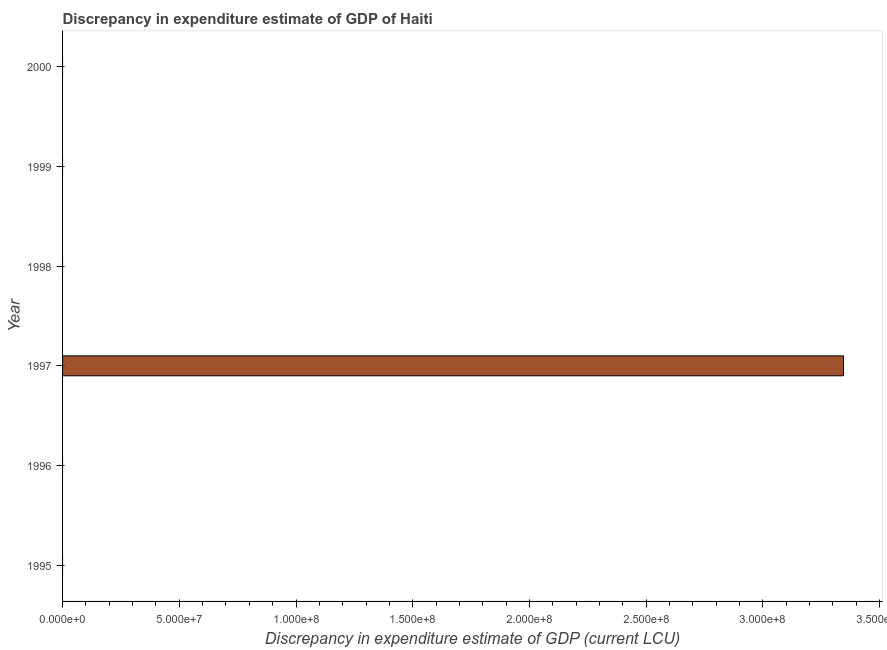Does the graph contain grids?
Provide a short and direct response. No. What is the title of the graph?
Your answer should be very brief. Discrepancy in expenditure estimate of GDP of Haiti. What is the label or title of the X-axis?
Provide a succinct answer. Discrepancy in expenditure estimate of GDP (current LCU). What is the label or title of the Y-axis?
Provide a short and direct response. Year. Across all years, what is the maximum discrepancy in expenditure estimate of gdp?
Your answer should be compact. 3.35e+08. Across all years, what is the minimum discrepancy in expenditure estimate of gdp?
Your response must be concise. 0. In which year was the discrepancy in expenditure estimate of gdp maximum?
Your answer should be compact. 1997. What is the sum of the discrepancy in expenditure estimate of gdp?
Provide a succinct answer. 3.35e+08. What is the average discrepancy in expenditure estimate of gdp per year?
Offer a terse response. 5.58e+07. What is the difference between the highest and the lowest discrepancy in expenditure estimate of gdp?
Make the answer very short. 3.35e+08. Are all the bars in the graph horizontal?
Offer a very short reply. Yes. How many years are there in the graph?
Provide a succinct answer. 6. What is the difference between two consecutive major ticks on the X-axis?
Keep it short and to the point. 5.00e+07. Are the values on the major ticks of X-axis written in scientific E-notation?
Your answer should be very brief. Yes. What is the Discrepancy in expenditure estimate of GDP (current LCU) in 1997?
Provide a short and direct response. 3.35e+08. What is the Discrepancy in expenditure estimate of GDP (current LCU) of 1999?
Give a very brief answer. 0. 